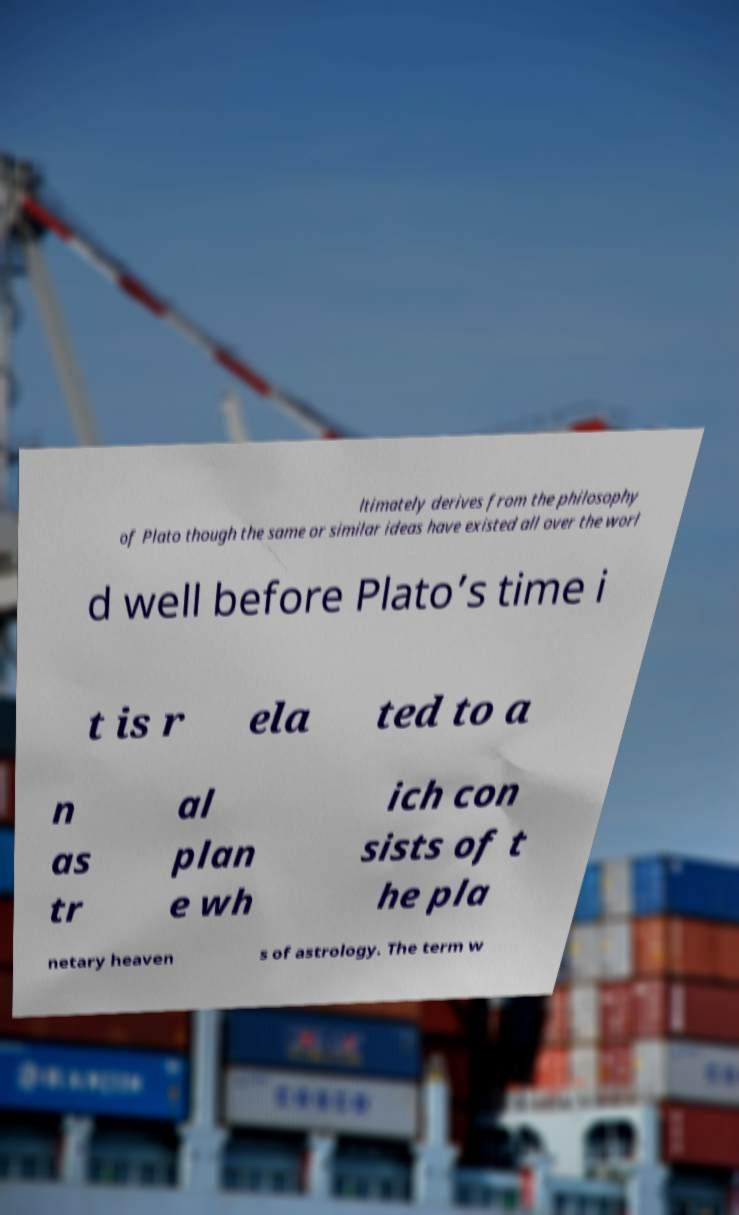Can you read and provide the text displayed in the image?This photo seems to have some interesting text. Can you extract and type it out for me? ltimately derives from the philosophy of Plato though the same or similar ideas have existed all over the worl d well before Plato’s time i t is r ela ted to a n as tr al plan e wh ich con sists of t he pla netary heaven s of astrology. The term w 